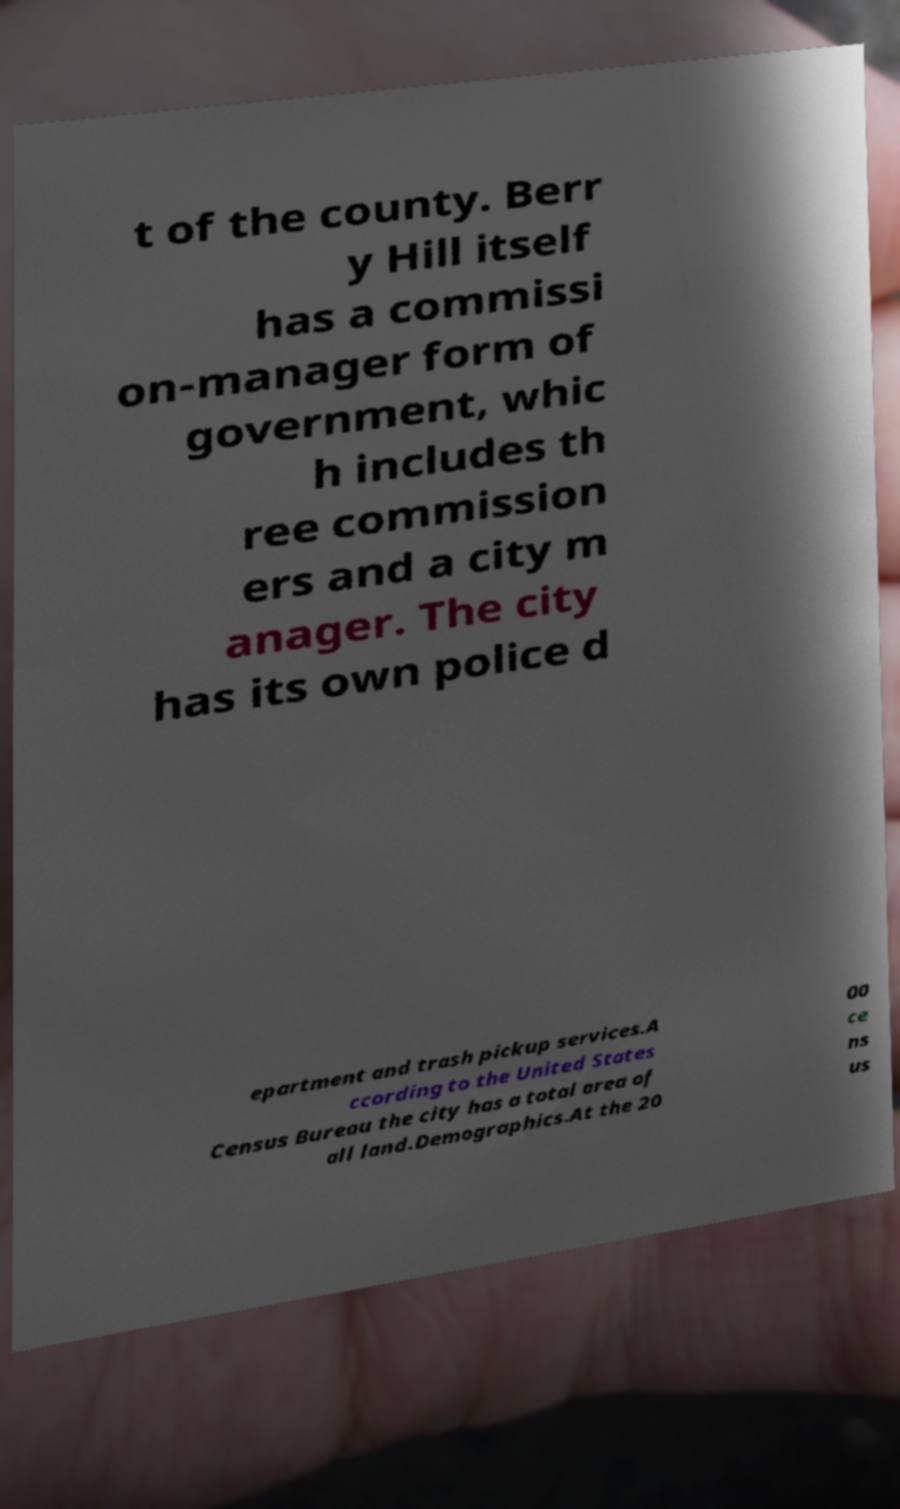What messages or text are displayed in this image? I need them in a readable, typed format. t of the county. Berr y Hill itself has a commissi on-manager form of government, whic h includes th ree commission ers and a city m anager. The city has its own police d epartment and trash pickup services.A ccording to the United States Census Bureau the city has a total area of all land.Demographics.At the 20 00 ce ns us 